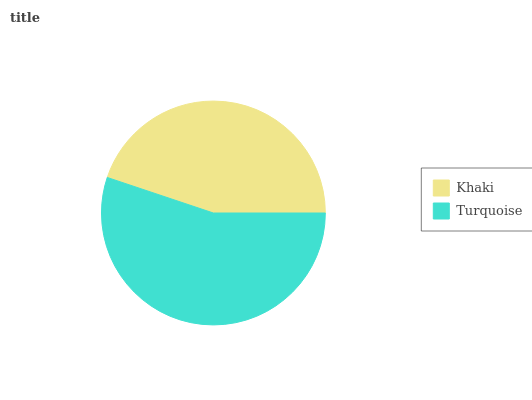Is Khaki the minimum?
Answer yes or no. Yes. Is Turquoise the maximum?
Answer yes or no. Yes. Is Turquoise the minimum?
Answer yes or no. No. Is Turquoise greater than Khaki?
Answer yes or no. Yes. Is Khaki less than Turquoise?
Answer yes or no. Yes. Is Khaki greater than Turquoise?
Answer yes or no. No. Is Turquoise less than Khaki?
Answer yes or no. No. Is Turquoise the high median?
Answer yes or no. Yes. Is Khaki the low median?
Answer yes or no. Yes. Is Khaki the high median?
Answer yes or no. No. Is Turquoise the low median?
Answer yes or no. No. 